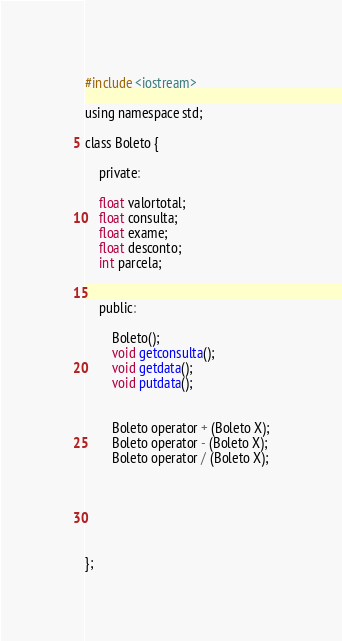Convert code to text. <code><loc_0><loc_0><loc_500><loc_500><_C_>#include <iostream>

using namespace std;

class Boleto {

	private:

    float valortotal;
	float consulta;
	float exame;
	float desconto;
	int parcela;


	public:

		Boleto();
		void getconsulta();
		void getdata();
		void putdata();


		Boleto operator + (Boleto X);
		Boleto operator - (Boleto X);
		Boleto operator / (Boleto X);






};
</code> 